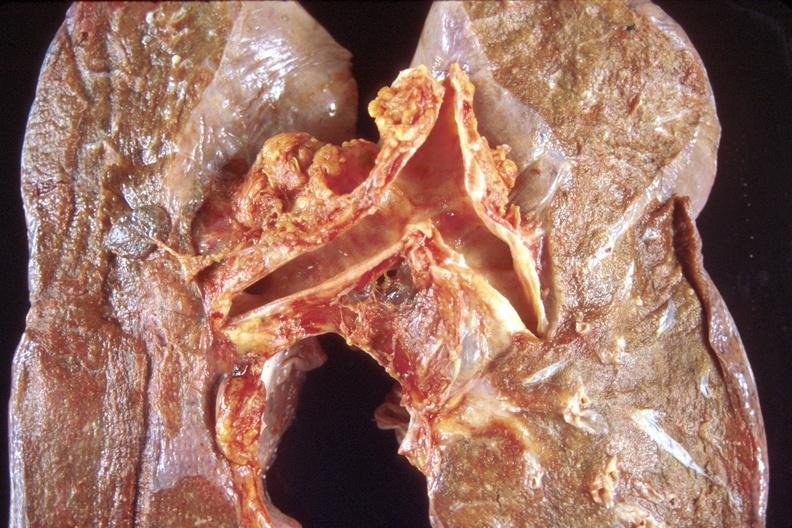does this image show normal lung?
Answer the question using a single word or phrase. Yes 